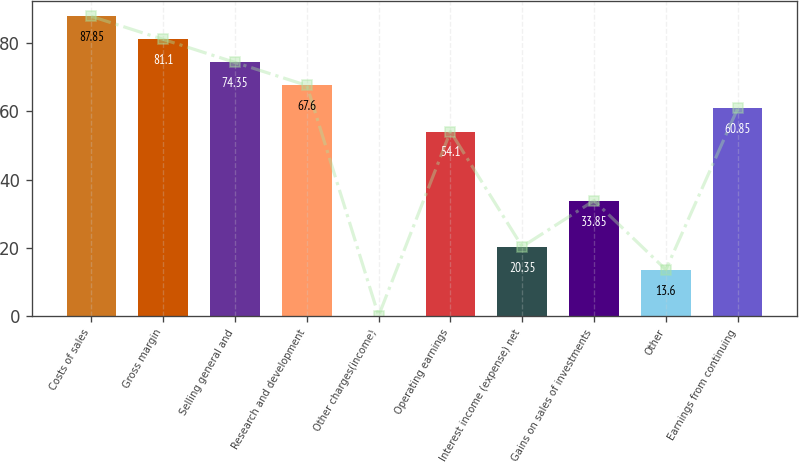Convert chart. <chart><loc_0><loc_0><loc_500><loc_500><bar_chart><fcel>Costs of sales<fcel>Gross margin<fcel>Selling general and<fcel>Research and development<fcel>Other charges(income)<fcel>Operating earnings<fcel>Interest income (expense) net<fcel>Gains on sales of investments<fcel>Other<fcel>Earnings from continuing<nl><fcel>87.85<fcel>81.1<fcel>74.35<fcel>67.6<fcel>0.1<fcel>54.1<fcel>20.35<fcel>33.85<fcel>13.6<fcel>60.85<nl></chart> 